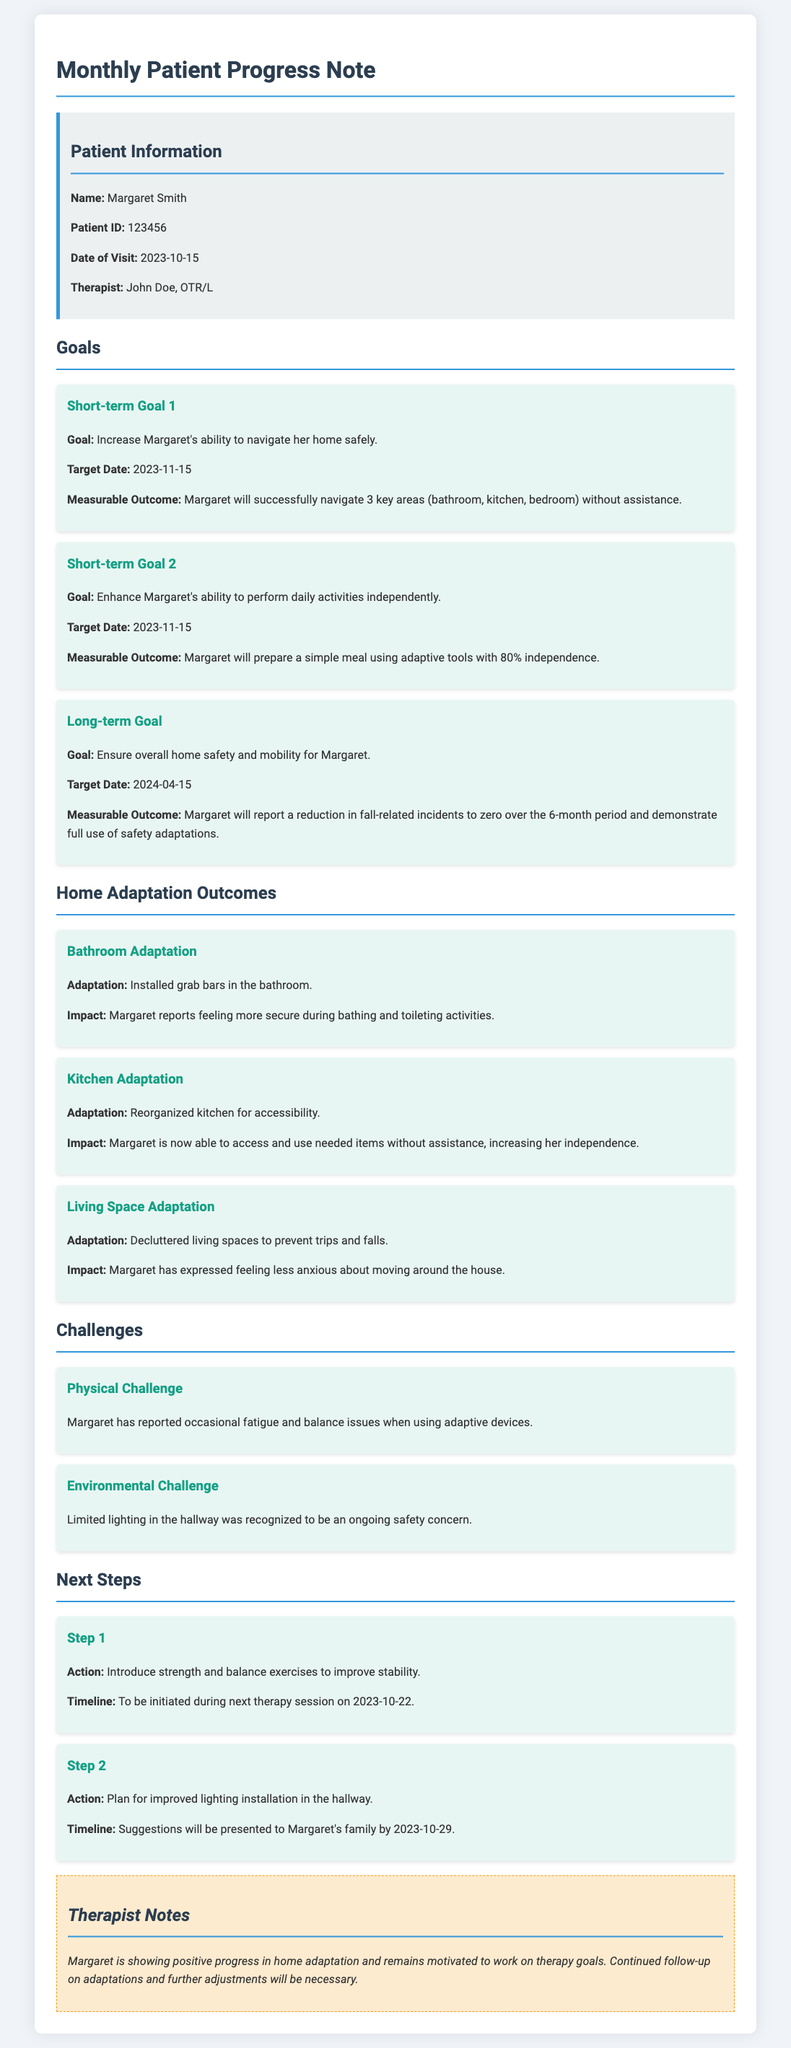What is the patient's name? The patient's name is mentioned at the top of the document in the patient information section.
Answer: Margaret Smith When is the target date for the short-term goals? The target date for both short-term goals is outlined clearly in the goals section of the document.
Answer: 2023-11-15 What adaptations were made in the bathroom? The document details specific adaptations made in each area, including the bathroom.
Answer: Installed grab bars What is the main physical challenge reported by Margaret? The physical challenge is highlighted in the challenges section of the document, indicating issues faced by the patient.
Answer: Fatigue and balance issues How many key areas does Margaret aim to navigate without assistance? This number is specified in the measurable outcome for the first short-term goal in the goals section.
Answer: 3 key areas What is the long-term goal for Margaret's home safety? The long-term goal is explicitly stated in the goals section, summarizing the overarching objective.
Answer: Ensure overall home safety and mobility What action is suggested for the next therapy session? The next steps section specifies the planned actions for Margaret's upcoming therapy session.
Answer: Introduce strength and balance exercises What improvements will be proposed for the hallway? The next steps section outlines proposed actions to improve Margaret's home environment.
Answer: Improved lighting installation What is the impact of the kitchen adaptation? The impact of the adaptation is described in the context of the kitchen adaptation in the document.
Answer: Increasing her independence 